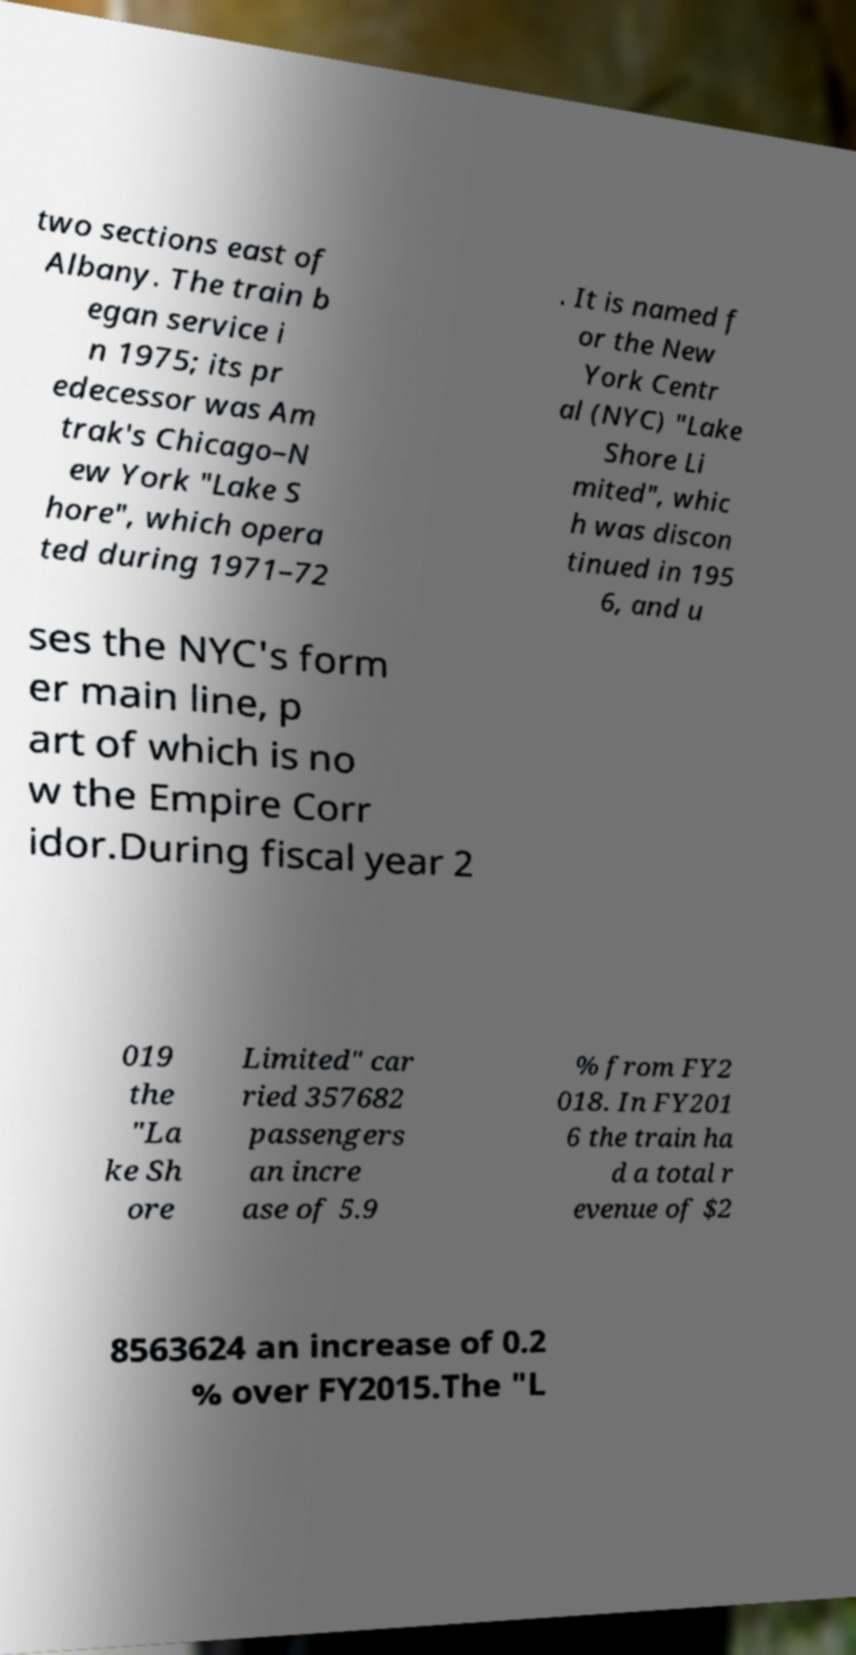Can you read and provide the text displayed in the image?This photo seems to have some interesting text. Can you extract and type it out for me? two sections east of Albany. The train b egan service i n 1975; its pr edecessor was Am trak's Chicago–N ew York "Lake S hore", which opera ted during 1971–72 . It is named f or the New York Centr al (NYC) "Lake Shore Li mited", whic h was discon tinued in 195 6, and u ses the NYC's form er main line, p art of which is no w the Empire Corr idor.During fiscal year 2 019 the "La ke Sh ore Limited" car ried 357682 passengers an incre ase of 5.9 % from FY2 018. In FY201 6 the train ha d a total r evenue of $2 8563624 an increase of 0.2 % over FY2015.The "L 